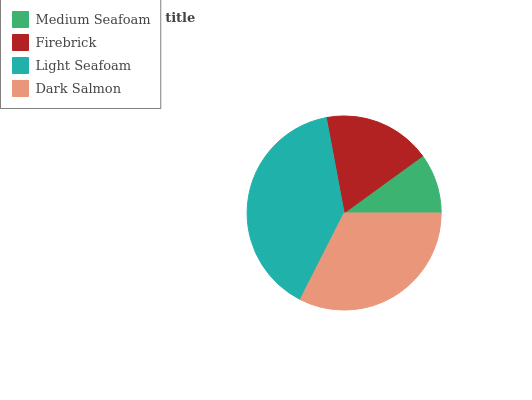Is Medium Seafoam the minimum?
Answer yes or no. Yes. Is Light Seafoam the maximum?
Answer yes or no. Yes. Is Firebrick the minimum?
Answer yes or no. No. Is Firebrick the maximum?
Answer yes or no. No. Is Firebrick greater than Medium Seafoam?
Answer yes or no. Yes. Is Medium Seafoam less than Firebrick?
Answer yes or no. Yes. Is Medium Seafoam greater than Firebrick?
Answer yes or no. No. Is Firebrick less than Medium Seafoam?
Answer yes or no. No. Is Dark Salmon the high median?
Answer yes or no. Yes. Is Firebrick the low median?
Answer yes or no. Yes. Is Light Seafoam the high median?
Answer yes or no. No. Is Medium Seafoam the low median?
Answer yes or no. No. 